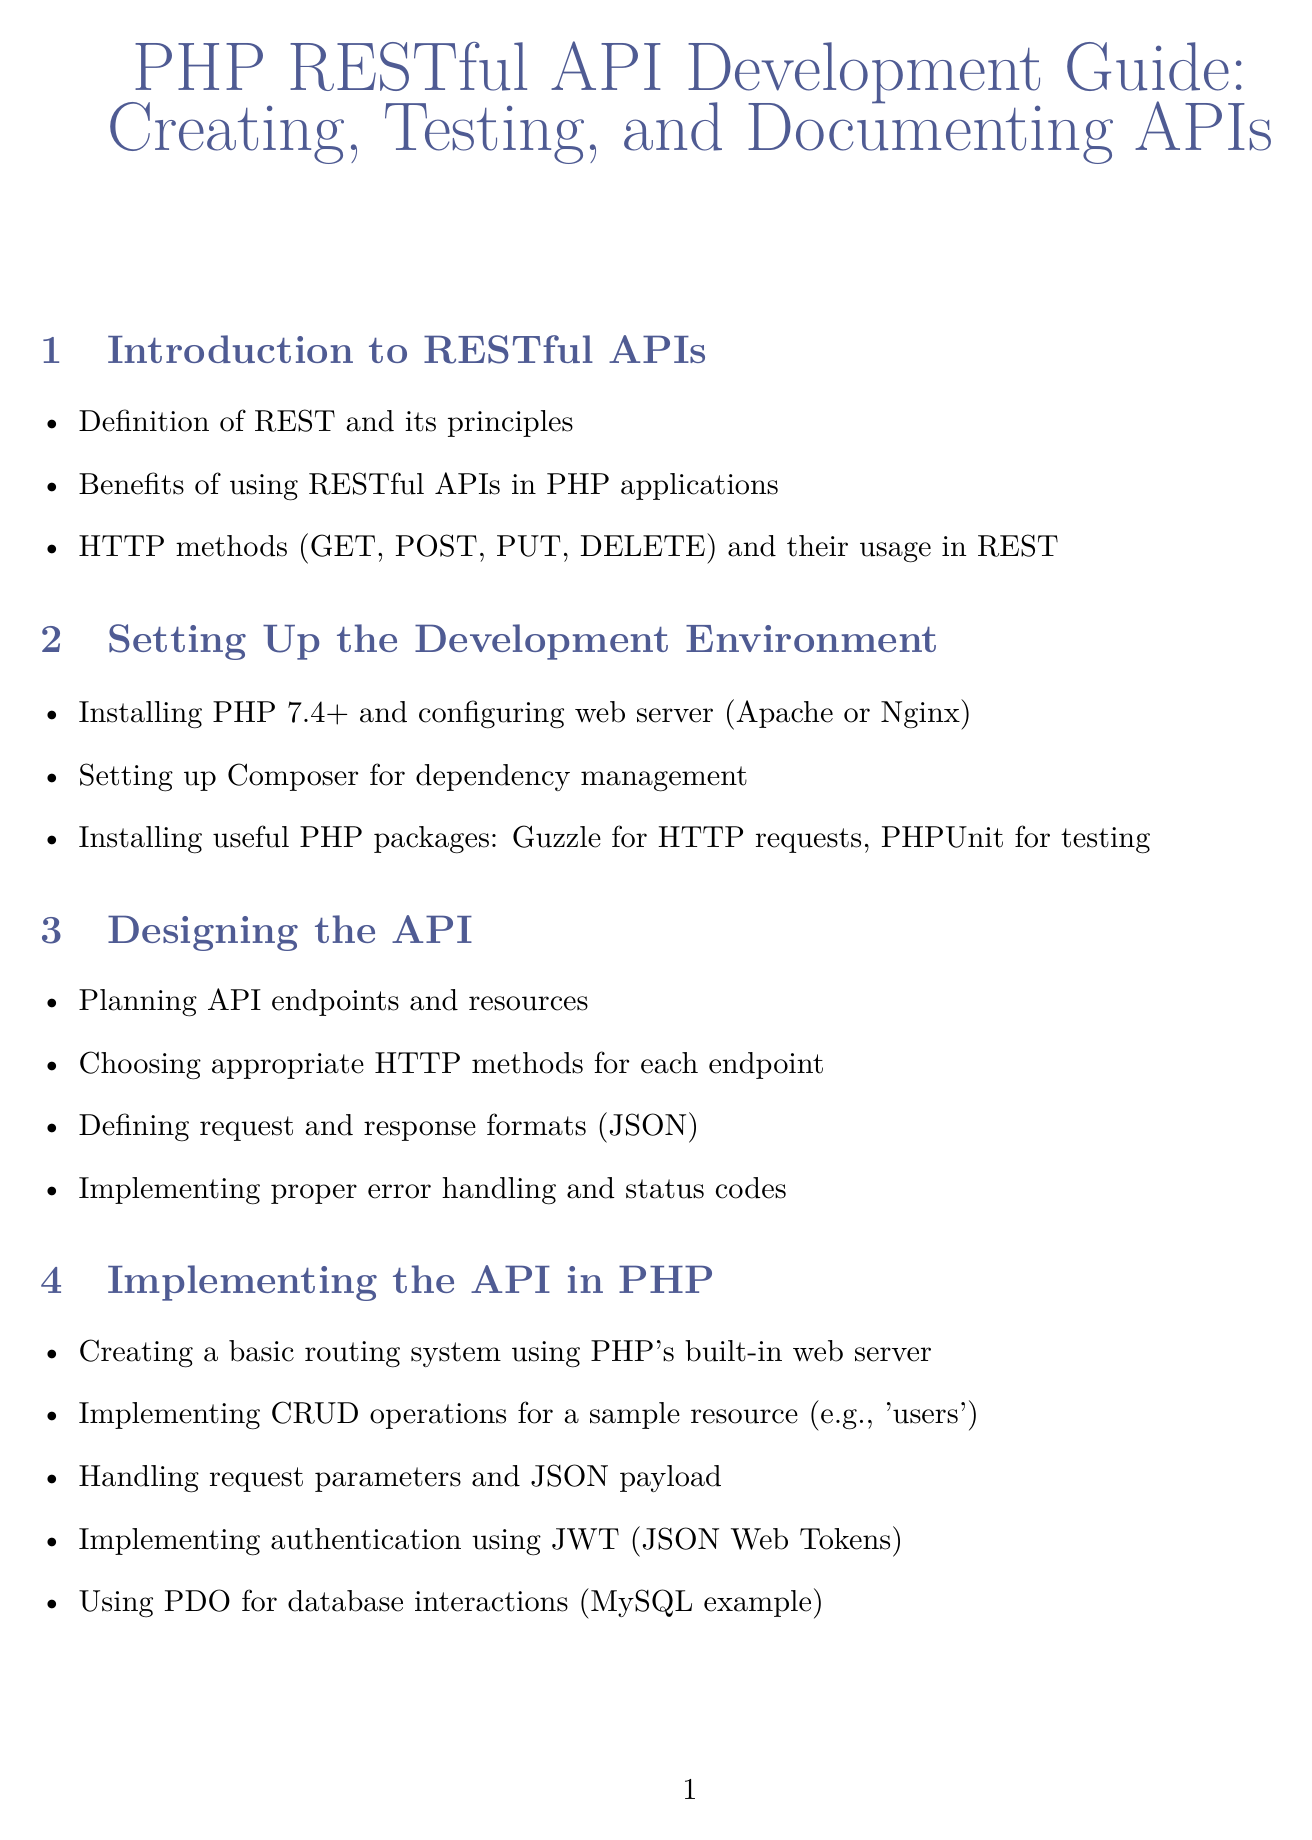What are the main benefits of using RESTful APIs? The benefits of using RESTful APIs are outlined in the introduction section, emphasizing improved scalability, performance, and ease of use in PHP applications.
Answer: Improved scalability, performance, and ease of use Which HTTP methods are included in the guide? The document lists the HTTP methods that are essential for RESTful APIs in the introduction, which includes methods for resource manipulation.
Answer: GET, POST, PUT, DELETE What tool is recommended for testing APIs? In the testing section, the document mentions specific tools used for API testing, which enhance the testing process.
Answer: Postman What caching strategies are discussed for performance optimization? The performance optimization section highlights strategies to enhance API performance, particularly emphasizing specific tools for caching data.
Answer: Redis or Memcached What is the primary authentication method mentioned in implementing the API? The document specifies the main authentication method utilized for securing API requests in the implementation section.
Answer: JWT (JSON Web Tokens) How many sections are there in the document? The total number of sections in the document covers various aspects of RESTful API development, indicating its comprehensive nature.
Answer: Nine 